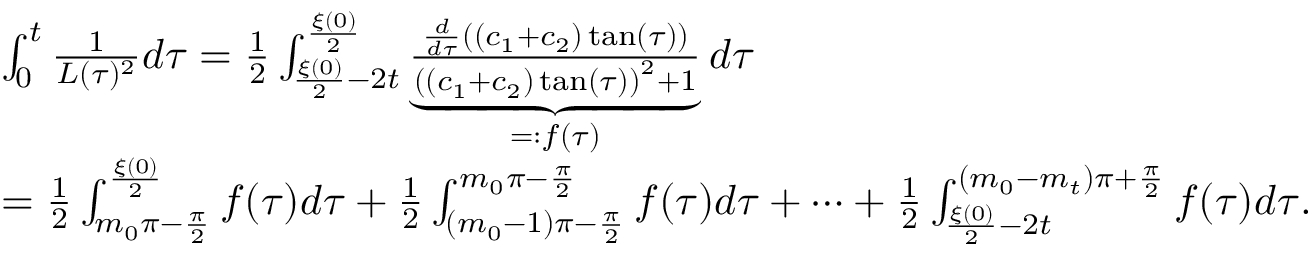Convert formula to latex. <formula><loc_0><loc_0><loc_500><loc_500>\begin{array} { r l } & { \int _ { 0 } ^ { t } \frac { 1 } { L ( \tau ) ^ { 2 } } d \tau = \frac { 1 } { 2 } \int _ { \frac { \xi ( 0 ) } { 2 } - 2 t } ^ { \frac { \xi ( 0 ) } { 2 } } \underbrace { \frac { \frac { d } { d \tau } \left ( ( c _ { 1 } + c _ { 2 } ) \tan ( \tau ) \right ) } { \left ( ( c _ { 1 } + c _ { 2 } ) \tan ( \tau ) \right ) ^ { 2 } + 1 } } _ { = \colon f ( \tau ) } d \tau } \\ & { = \frac { 1 } { 2 } \int _ { m _ { 0 } \pi - \frac { \pi } { 2 } } ^ { \frac { \xi ( 0 ) } { 2 } } f ( \tau ) d \tau + \frac { 1 } { 2 } \int _ { ( m _ { 0 } - 1 ) \pi - \frac { \pi } { 2 } } ^ { m _ { 0 } \pi - \frac { \pi } { 2 } } f ( \tau ) d \tau + \dots + \frac { 1 } { 2 } \int _ { \frac { \xi ( 0 ) } { 2 } - 2 t } ^ { ( m _ { 0 } - m _ { t } ) \pi + \frac { \pi } { 2 } } f ( \tau ) d \tau . } \end{array}</formula> 